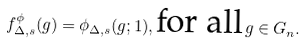Convert formula to latex. <formula><loc_0><loc_0><loc_500><loc_500>f _ { \Delta , s } ^ { \phi } ( g ) = \phi _ { \Delta , s } ( g ; 1 ) , \text {for all} \, g \in G _ { n } .</formula> 